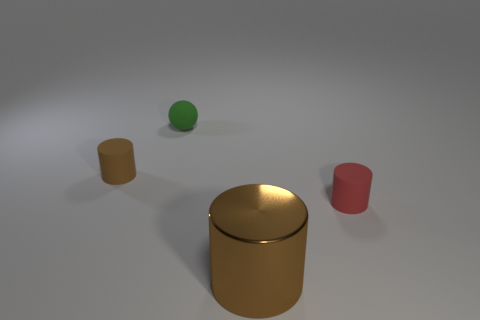Subtract all tiny red matte cylinders. How many cylinders are left? 2 Add 4 tiny brown objects. How many objects exist? 8 Subtract all red cylinders. How many cylinders are left? 2 Subtract 2 cylinders. How many cylinders are left? 1 Subtract all cylinders. How many objects are left? 1 Subtract 1 green spheres. How many objects are left? 3 Subtract all brown cylinders. Subtract all yellow cubes. How many cylinders are left? 1 Subtract all brown cylinders. How many yellow balls are left? 0 Subtract all large gray metal cylinders. Subtract all balls. How many objects are left? 3 Add 3 metal cylinders. How many metal cylinders are left? 4 